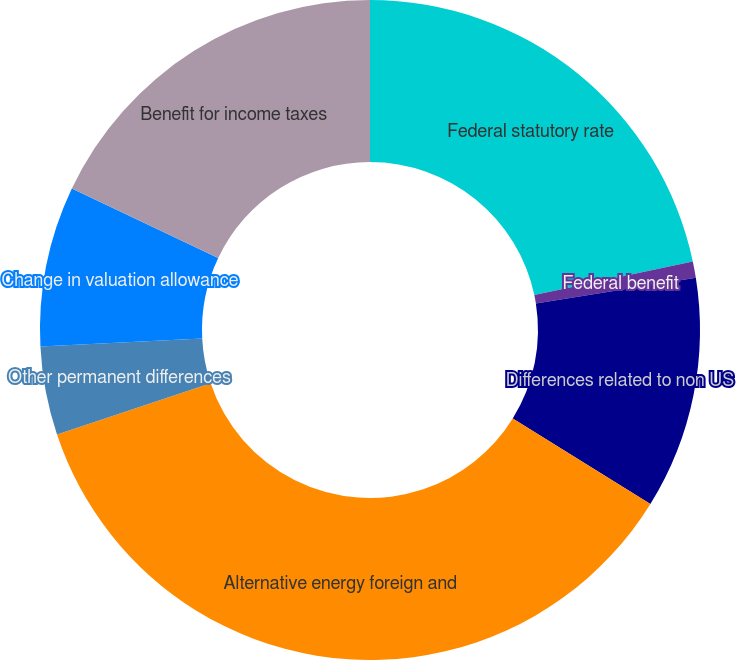Convert chart. <chart><loc_0><loc_0><loc_500><loc_500><pie_chart><fcel>Federal statutory rate<fcel>Federal benefit<fcel>Differences related to non US<fcel>Alternative energy foreign and<fcel>Other permanent differences<fcel>Change in valuation allowance<fcel>Benefit for income taxes<nl><fcel>21.67%<fcel>0.8%<fcel>11.37%<fcel>36.03%<fcel>4.33%<fcel>7.85%<fcel>17.95%<nl></chart> 